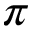<formula> <loc_0><loc_0><loc_500><loc_500>\pi</formula> 